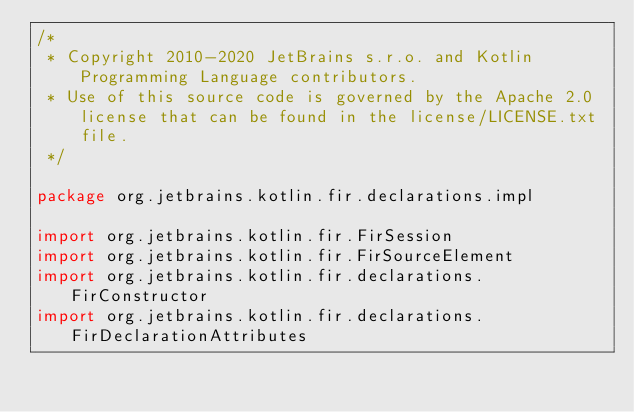<code> <loc_0><loc_0><loc_500><loc_500><_Kotlin_>/*
 * Copyright 2010-2020 JetBrains s.r.o. and Kotlin Programming Language contributors.
 * Use of this source code is governed by the Apache 2.0 license that can be found in the license/LICENSE.txt file.
 */

package org.jetbrains.kotlin.fir.declarations.impl

import org.jetbrains.kotlin.fir.FirSession
import org.jetbrains.kotlin.fir.FirSourceElement
import org.jetbrains.kotlin.fir.declarations.FirConstructor
import org.jetbrains.kotlin.fir.declarations.FirDeclarationAttributes</code> 